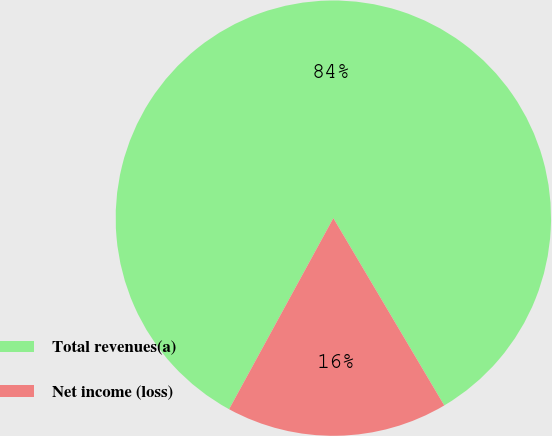Convert chart. <chart><loc_0><loc_0><loc_500><loc_500><pie_chart><fcel>Total revenues(a)<fcel>Net income (loss)<nl><fcel>83.54%<fcel>16.46%<nl></chart> 